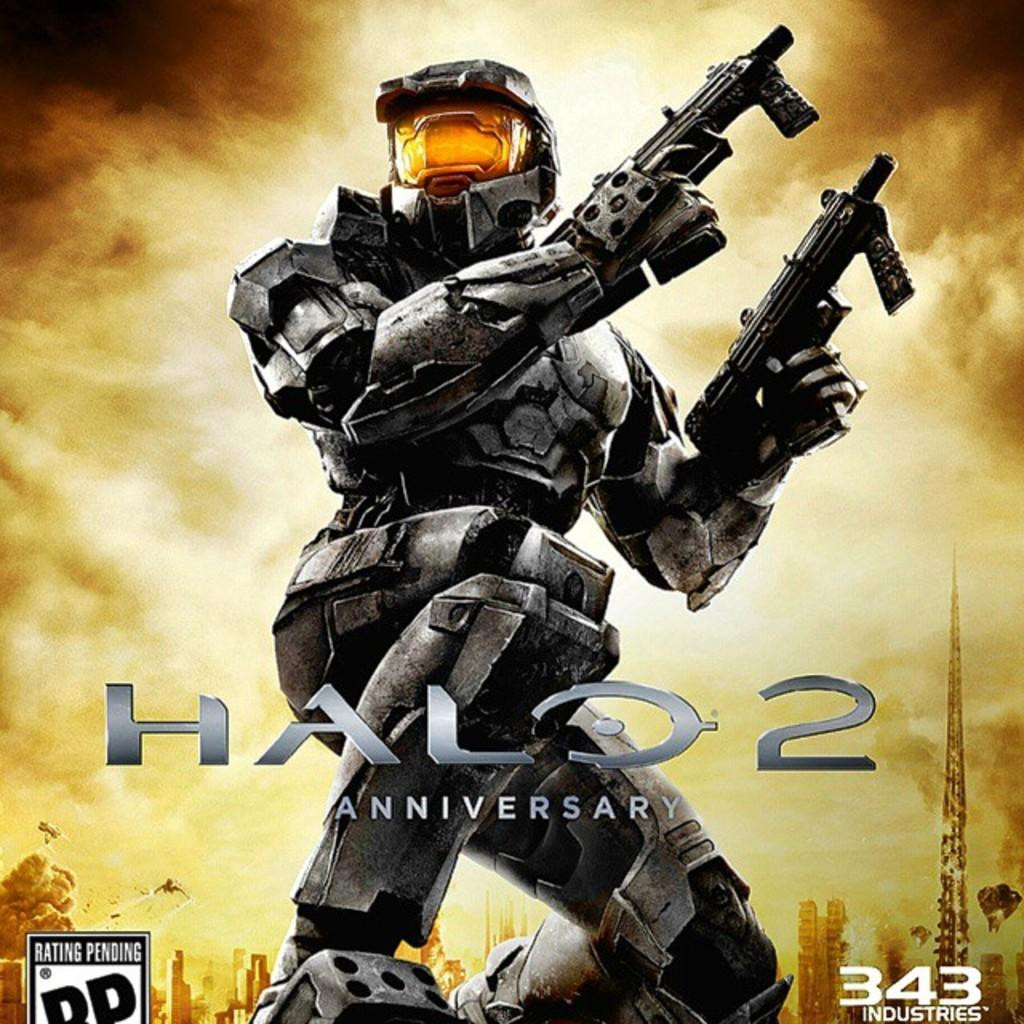Provide a one-sentence caption for the provided image. Halo 2 Anniversy shows a man in full gear with two guns. 